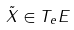<formula> <loc_0><loc_0><loc_500><loc_500>\tilde { X } \in T _ { e } E</formula> 